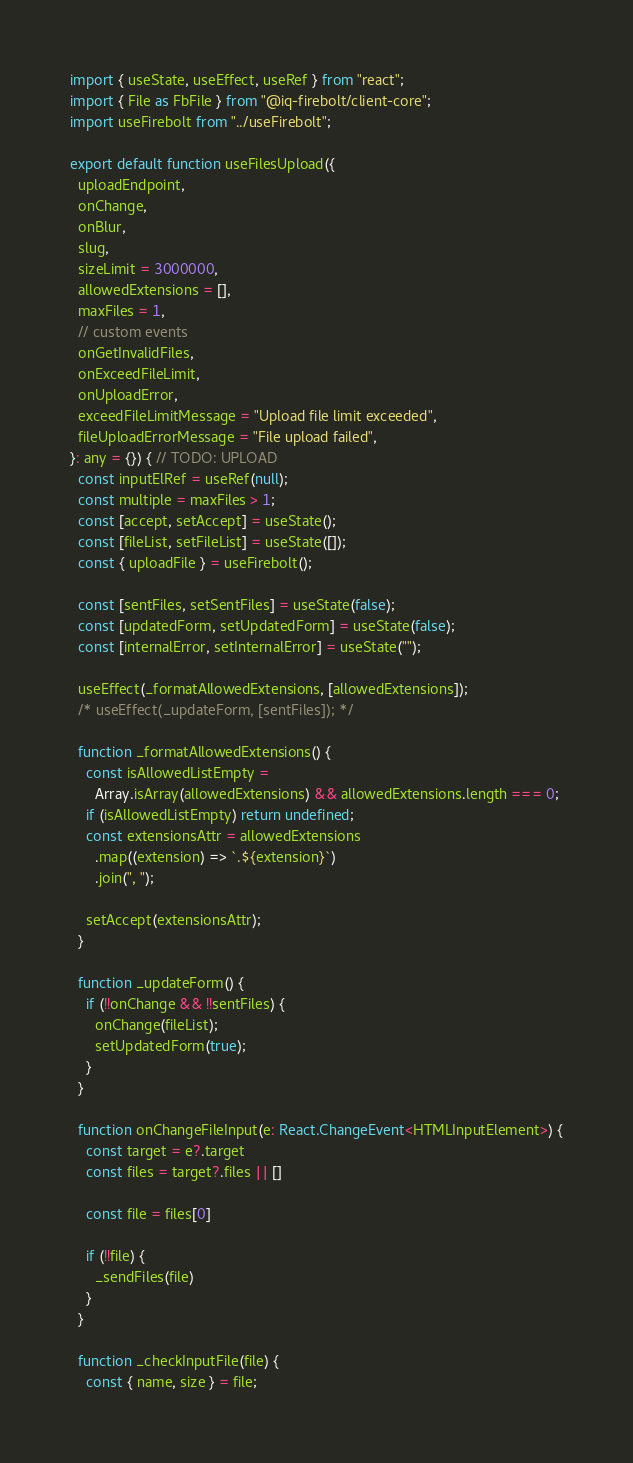Convert code to text. <code><loc_0><loc_0><loc_500><loc_500><_TypeScript_>import { useState, useEffect, useRef } from "react";
import { File as FbFile } from "@iq-firebolt/client-core";
import useFirebolt from "../useFirebolt";

export default function useFilesUpload({
  uploadEndpoint,
  onChange,
  onBlur,
  slug,
  sizeLimit = 3000000,
  allowedExtensions = [],
  maxFiles = 1,
  // custom events
  onGetInvalidFiles,
  onExceedFileLimit,
  onUploadError,
  exceedFileLimitMessage = "Upload file limit exceeded",
  fileUploadErrorMessage = "File upload failed",
}: any = {}) { // TODO: UPLOAD
  const inputElRef = useRef(null);
  const multiple = maxFiles > 1;
  const [accept, setAccept] = useState();
  const [fileList, setFileList] = useState([]);
  const { uploadFile } = useFirebolt(); 

  const [sentFiles, setSentFiles] = useState(false);
  const [updatedForm, setUpdatedForm] = useState(false);
  const [internalError, setInternalError] = useState("");

  useEffect(_formatAllowedExtensions, [allowedExtensions]);
  /* useEffect(_updateForm, [sentFiles]); */

  function _formatAllowedExtensions() {
    const isAllowedListEmpty =
      Array.isArray(allowedExtensions) && allowedExtensions.length === 0;
    if (isAllowedListEmpty) return undefined;
    const extensionsAttr = allowedExtensions
      .map((extension) => `.${extension}`)
      .join(", ");

    setAccept(extensionsAttr);
  }

  function _updateForm() {
    if (!!onChange && !!sentFiles) {
      onChange(fileList);
      setUpdatedForm(true);
    }
  }

  function onChangeFileInput(e: React.ChangeEvent<HTMLInputElement>) {
    const target = e?.target
    const files = target?.files || []

    const file = files[0]

    if (!!file) {
      _sendFiles(file)
    }
  }

  function _checkInputFile(file) {
    const { name, size } = file;</code> 